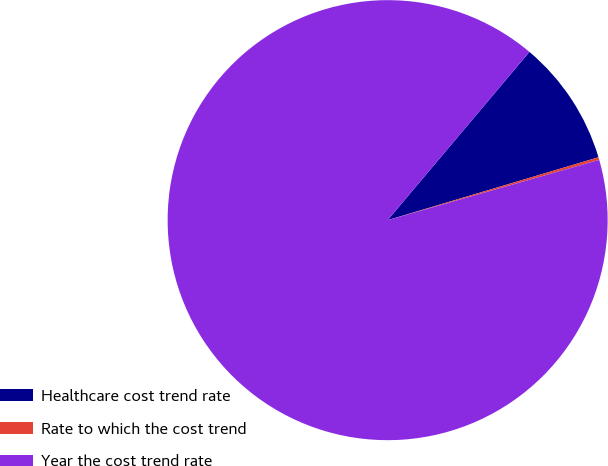Convert chart. <chart><loc_0><loc_0><loc_500><loc_500><pie_chart><fcel>Healthcare cost trend rate<fcel>Rate to which the cost trend<fcel>Year the cost trend rate<nl><fcel>9.24%<fcel>0.2%<fcel>90.56%<nl></chart> 